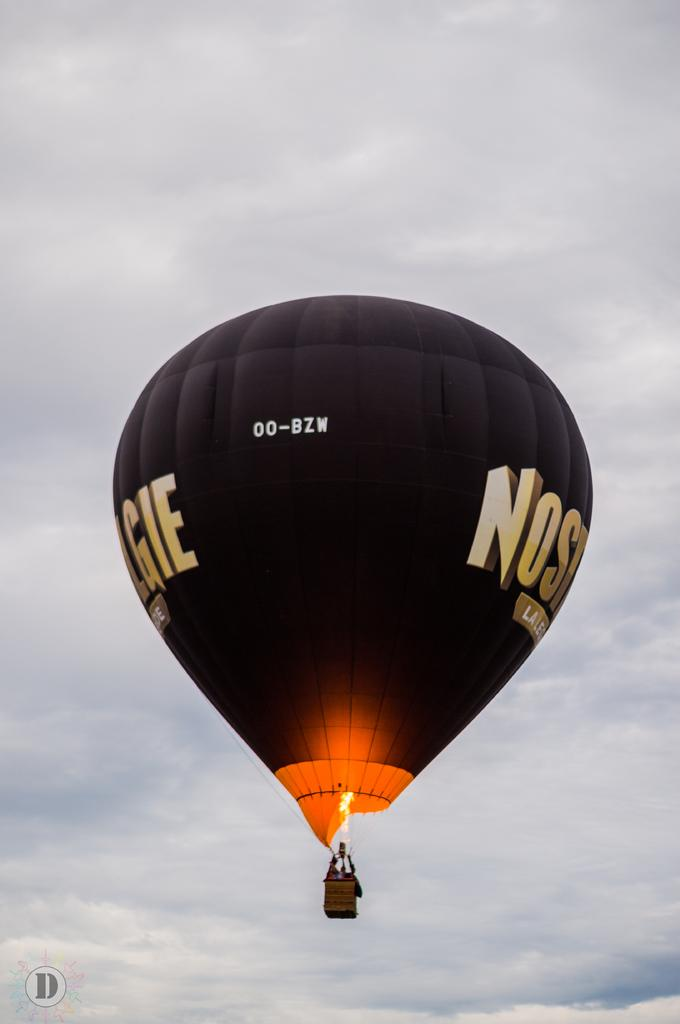<image>
Offer a succinct explanation of the picture presented. A black hot air balloon is floating in the sky with the letters NOSGIE on the side. 